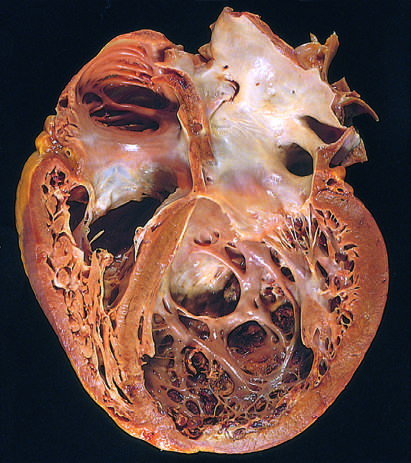how are four-chamber dilation and hypertrophy?
Answer the question using a single word or phrase. Evident 